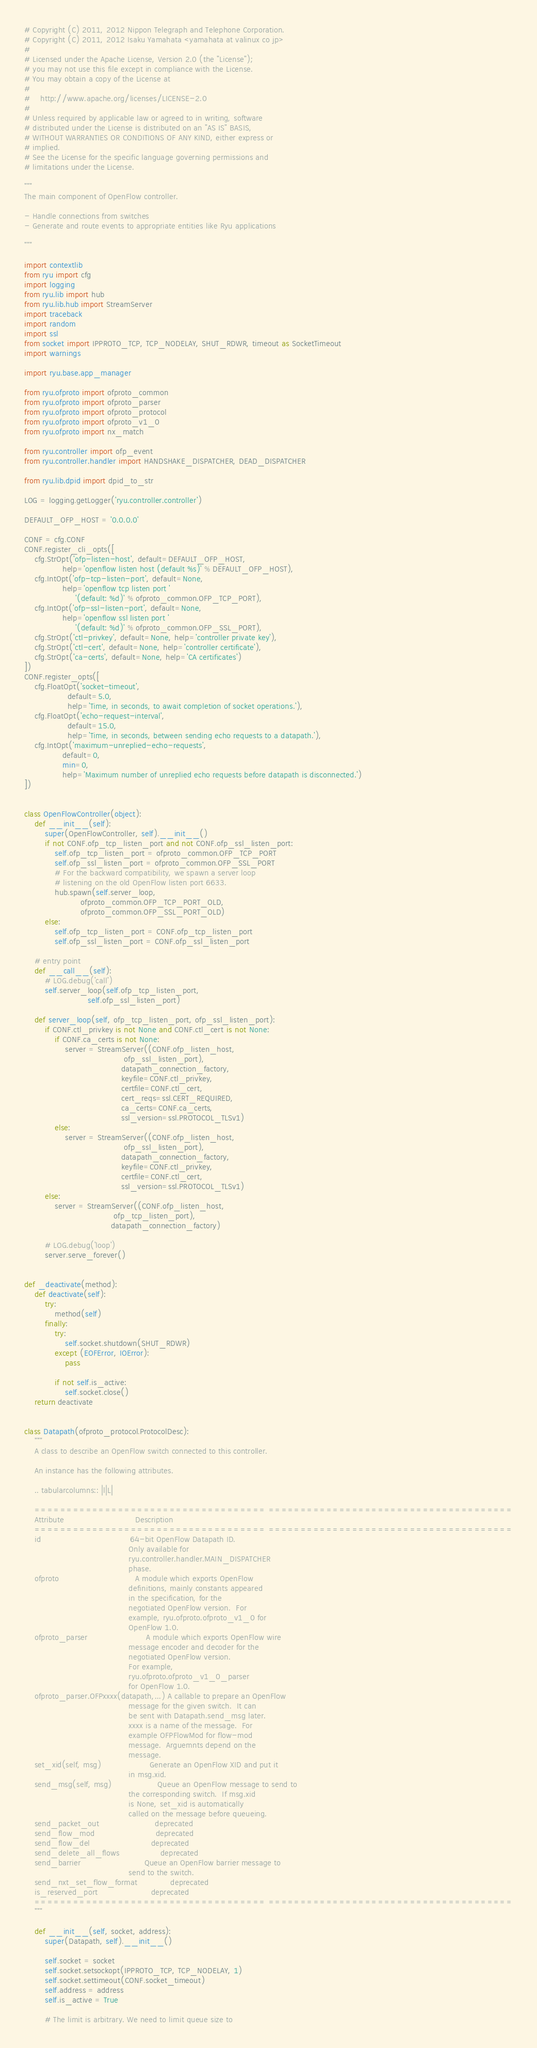Convert code to text. <code><loc_0><loc_0><loc_500><loc_500><_Python_># Copyright (C) 2011, 2012 Nippon Telegraph and Telephone Corporation.
# Copyright (C) 2011, 2012 Isaku Yamahata <yamahata at valinux co jp>
#
# Licensed under the Apache License, Version 2.0 (the "License");
# you may not use this file except in compliance with the License.
# You may obtain a copy of the License at
#
#    http://www.apache.org/licenses/LICENSE-2.0
#
# Unless required by applicable law or agreed to in writing, software
# distributed under the License is distributed on an "AS IS" BASIS,
# WITHOUT WARRANTIES OR CONDITIONS OF ANY KIND, either express or
# implied.
# See the License for the specific language governing permissions and
# limitations under the License.

"""
The main component of OpenFlow controller.

- Handle connections from switches
- Generate and route events to appropriate entities like Ryu applications

"""

import contextlib
from ryu import cfg
import logging
from ryu.lib import hub
from ryu.lib.hub import StreamServer
import traceback
import random
import ssl
from socket import IPPROTO_TCP, TCP_NODELAY, SHUT_RDWR, timeout as SocketTimeout
import warnings

import ryu.base.app_manager

from ryu.ofproto import ofproto_common
from ryu.ofproto import ofproto_parser
from ryu.ofproto import ofproto_protocol
from ryu.ofproto import ofproto_v1_0
from ryu.ofproto import nx_match

from ryu.controller import ofp_event
from ryu.controller.handler import HANDSHAKE_DISPATCHER, DEAD_DISPATCHER

from ryu.lib.dpid import dpid_to_str

LOG = logging.getLogger('ryu.controller.controller')

DEFAULT_OFP_HOST = '0.0.0.0'

CONF = cfg.CONF
CONF.register_cli_opts([
    cfg.StrOpt('ofp-listen-host', default=DEFAULT_OFP_HOST,
               help='openflow listen host (default %s)' % DEFAULT_OFP_HOST),
    cfg.IntOpt('ofp-tcp-listen-port', default=None,
               help='openflow tcp listen port '
                    '(default: %d)' % ofproto_common.OFP_TCP_PORT),
    cfg.IntOpt('ofp-ssl-listen-port', default=None,
               help='openflow ssl listen port '
                    '(default: %d)' % ofproto_common.OFP_SSL_PORT),
    cfg.StrOpt('ctl-privkey', default=None, help='controller private key'),
    cfg.StrOpt('ctl-cert', default=None, help='controller certificate'),
    cfg.StrOpt('ca-certs', default=None, help='CA certificates')
])
CONF.register_opts([
    cfg.FloatOpt('socket-timeout',
                 default=5.0,
                 help='Time, in seconds, to await completion of socket operations.'),
    cfg.FloatOpt('echo-request-interval',
                 default=15.0,
                 help='Time, in seconds, between sending echo requests to a datapath.'),
    cfg.IntOpt('maximum-unreplied-echo-requests',
               default=0,
               min=0,
               help='Maximum number of unreplied echo requests before datapath is disconnected.')
])


class OpenFlowController(object):
    def __init__(self):
        super(OpenFlowController, self).__init__()
        if not CONF.ofp_tcp_listen_port and not CONF.ofp_ssl_listen_port:
            self.ofp_tcp_listen_port = ofproto_common.OFP_TCP_PORT
            self.ofp_ssl_listen_port = ofproto_common.OFP_SSL_PORT
            # For the backward compatibility, we spawn a server loop
            # listening on the old OpenFlow listen port 6633.
            hub.spawn(self.server_loop,
                      ofproto_common.OFP_TCP_PORT_OLD,
                      ofproto_common.OFP_SSL_PORT_OLD)
        else:
            self.ofp_tcp_listen_port = CONF.ofp_tcp_listen_port
            self.ofp_ssl_listen_port = CONF.ofp_ssl_listen_port

    # entry point
    def __call__(self):
        # LOG.debug('call')
        self.server_loop(self.ofp_tcp_listen_port,
                         self.ofp_ssl_listen_port)

    def server_loop(self, ofp_tcp_listen_port, ofp_ssl_listen_port):
        if CONF.ctl_privkey is not None and CONF.ctl_cert is not None:
            if CONF.ca_certs is not None:
                server = StreamServer((CONF.ofp_listen_host,
                                       ofp_ssl_listen_port),
                                      datapath_connection_factory,
                                      keyfile=CONF.ctl_privkey,
                                      certfile=CONF.ctl_cert,
                                      cert_reqs=ssl.CERT_REQUIRED,
                                      ca_certs=CONF.ca_certs,
                                      ssl_version=ssl.PROTOCOL_TLSv1)
            else:
                server = StreamServer((CONF.ofp_listen_host,
                                       ofp_ssl_listen_port),
                                      datapath_connection_factory,
                                      keyfile=CONF.ctl_privkey,
                                      certfile=CONF.ctl_cert,
                                      ssl_version=ssl.PROTOCOL_TLSv1)
        else:
            server = StreamServer((CONF.ofp_listen_host,
                                   ofp_tcp_listen_port),
                                  datapath_connection_factory)

        # LOG.debug('loop')
        server.serve_forever()


def _deactivate(method):
    def deactivate(self):
        try:
            method(self)
        finally:
            try:
                self.socket.shutdown(SHUT_RDWR)
            except (EOFError, IOError):
                pass

            if not self.is_active:
                self.socket.close()
    return deactivate


class Datapath(ofproto_protocol.ProtocolDesc):
    """
    A class to describe an OpenFlow switch connected to this controller.

    An instance has the following attributes.

    .. tabularcolumns:: |l|L|

    ==================================== ======================================
    Attribute                            Description
    ==================================== ======================================
    id                                   64-bit OpenFlow Datapath ID.
                                         Only available for
                                         ryu.controller.handler.MAIN_DISPATCHER
                                         phase.
    ofproto                              A module which exports OpenFlow
                                         definitions, mainly constants appeared
                                         in the specification, for the
                                         negotiated OpenFlow version.  For
                                         example, ryu.ofproto.ofproto_v1_0 for
                                         OpenFlow 1.0.
    ofproto_parser                       A module which exports OpenFlow wire
                                         message encoder and decoder for the
                                         negotiated OpenFlow version.
                                         For example,
                                         ryu.ofproto.ofproto_v1_0_parser
                                         for OpenFlow 1.0.
    ofproto_parser.OFPxxxx(datapath,...) A callable to prepare an OpenFlow
                                         message for the given switch.  It can
                                         be sent with Datapath.send_msg later.
                                         xxxx is a name of the message.  For
                                         example OFPFlowMod for flow-mod
                                         message.  Arguemnts depend on the
                                         message.
    set_xid(self, msg)                   Generate an OpenFlow XID and put it
                                         in msg.xid.
    send_msg(self, msg)                  Queue an OpenFlow message to send to
                                         the corresponding switch.  If msg.xid
                                         is None, set_xid is automatically
                                         called on the message before queueing.
    send_packet_out                      deprecated
    send_flow_mod                        deprecated
    send_flow_del                        deprecated
    send_delete_all_flows                deprecated
    send_barrier                         Queue an OpenFlow barrier message to
                                         send to the switch.
    send_nxt_set_flow_format             deprecated
    is_reserved_port                     deprecated
    ==================================== ======================================
    """

    def __init__(self, socket, address):
        super(Datapath, self).__init__()

        self.socket = socket
        self.socket.setsockopt(IPPROTO_TCP, TCP_NODELAY, 1)
        self.socket.settimeout(CONF.socket_timeout)
        self.address = address
        self.is_active = True

        # The limit is arbitrary. We need to limit queue size to</code> 